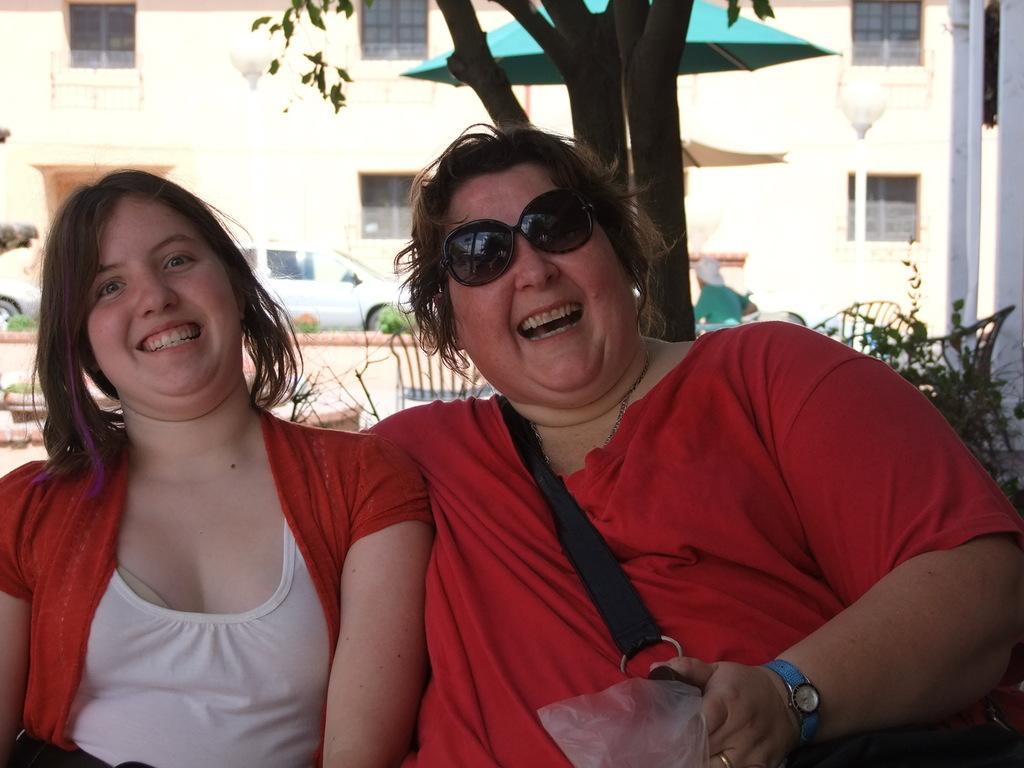Please provide a concise description of this image. In this picture there are two ladies in the center of the image and there is a building and tree at the top side of the image. 